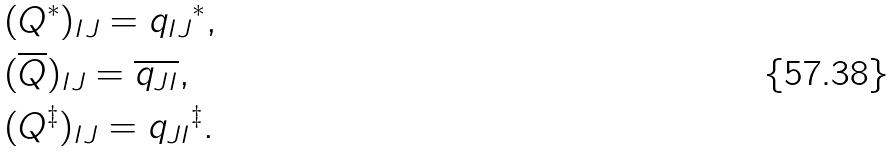<formula> <loc_0><loc_0><loc_500><loc_500>& ( { Q } ^ { * } ) _ { I J } = { q _ { I J } } ^ { * } , \\ & ( \overline { Q } ) _ { I J } = \overline { q _ { J I } } , \\ & ( { Q } ^ { \ddagger } ) _ { I J } = { q _ { J I } } ^ { \ddagger } .</formula> 